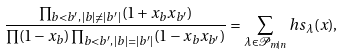<formula> <loc_0><loc_0><loc_500><loc_500>\frac { \prod _ { b < b ^ { \prime } , \, | b | \neq | b ^ { \prime } | } ( 1 + x _ { b } x _ { b ^ { \prime } } ) } { \prod ( 1 - x _ { b } ) \prod _ { b < b ^ { \prime } , \, | b | = | b ^ { \prime } | } ( 1 - x _ { b } x _ { b ^ { \prime } } ) } = \sum _ { \lambda \in \mathcal { P } _ { m | n } } h s _ { \lambda } ( x ) ,</formula> 